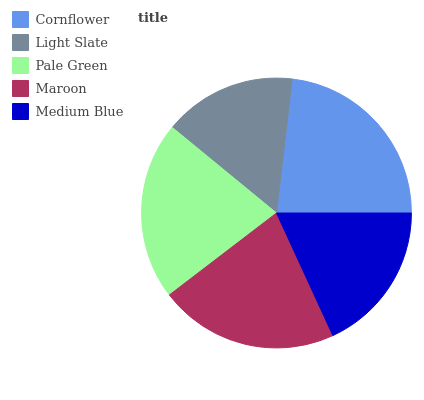Is Light Slate the minimum?
Answer yes or no. Yes. Is Cornflower the maximum?
Answer yes or no. Yes. Is Pale Green the minimum?
Answer yes or no. No. Is Pale Green the maximum?
Answer yes or no. No. Is Pale Green greater than Light Slate?
Answer yes or no. Yes. Is Light Slate less than Pale Green?
Answer yes or no. Yes. Is Light Slate greater than Pale Green?
Answer yes or no. No. Is Pale Green less than Light Slate?
Answer yes or no. No. Is Pale Green the high median?
Answer yes or no. Yes. Is Pale Green the low median?
Answer yes or no. Yes. Is Cornflower the high median?
Answer yes or no. No. Is Maroon the low median?
Answer yes or no. No. 